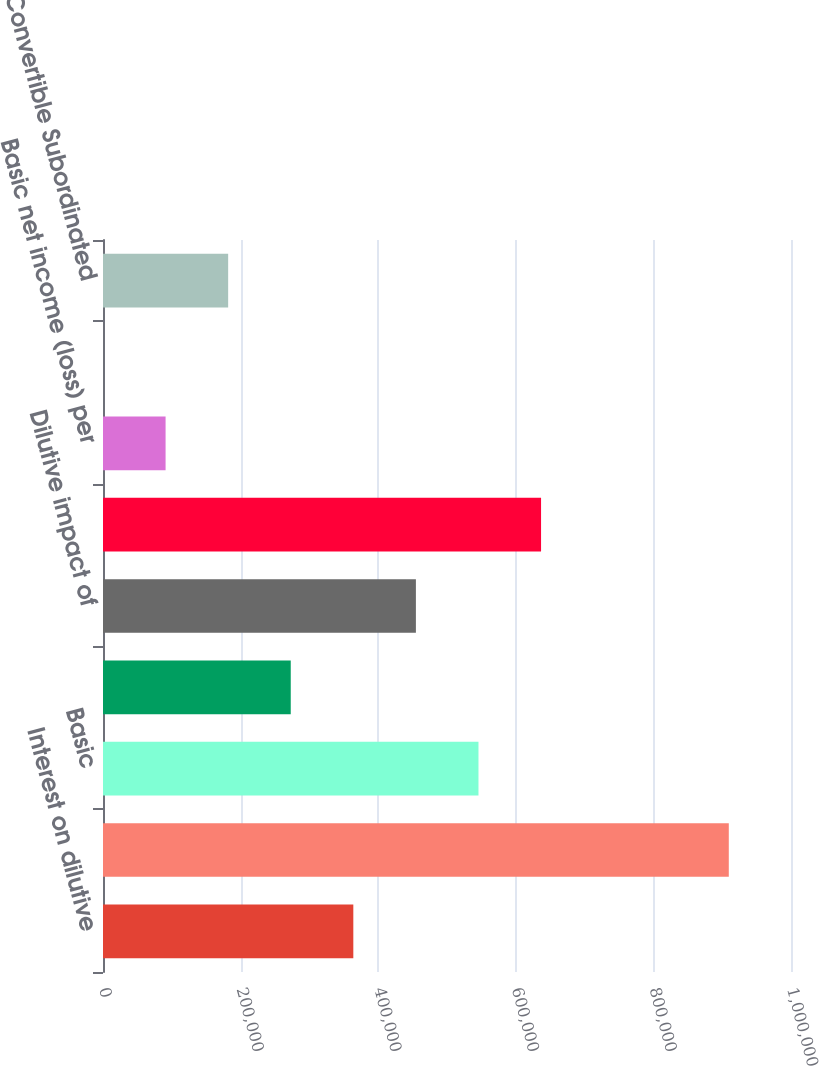Convert chart to OTSL. <chart><loc_0><loc_0><loc_500><loc_500><bar_chart><fcel>Interest on dilutive<fcel>Diluted net income (loss)<fcel>Basic<fcel>Dilutive impact of stock<fcel>Dilutive impact of<fcel>Diluted<fcel>Basic net income (loss) per<fcel>Diluted net income (loss) per<fcel>3 Convertible Subordinated<nl><fcel>363835<fcel>909585<fcel>545752<fcel>272877<fcel>454793<fcel>636710<fcel>90960.3<fcel>1.98<fcel>181919<nl></chart> 